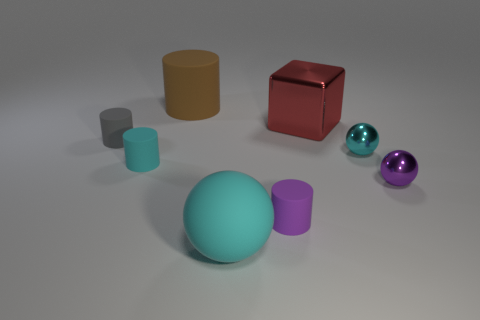What shape is the gray thing?
Keep it short and to the point. Cylinder. What is the color of the other sphere that is the same size as the purple sphere?
Give a very brief answer. Cyan. What number of cyan objects are either metal things or big shiny things?
Make the answer very short. 1. Is the number of big cyan rubber things greater than the number of small gray rubber balls?
Your answer should be very brief. Yes. There is a cylinder to the right of the brown cylinder; is its size the same as the matte thing that is behind the small gray matte cylinder?
Offer a terse response. No. The sphere that is in front of the small matte cylinder to the right of the large thing behind the big red object is what color?
Your answer should be compact. Cyan. Are there any small cyan rubber things that have the same shape as the brown thing?
Make the answer very short. Yes. Are there more tiny purple cylinders that are on the left side of the red cube than large blue rubber cubes?
Ensure brevity in your answer.  Yes. How many shiny objects are cyan cylinders or tiny cyan objects?
Offer a terse response. 1. There is a object that is right of the tiny purple cylinder and behind the tiny gray object; how big is it?
Your answer should be compact. Large. 